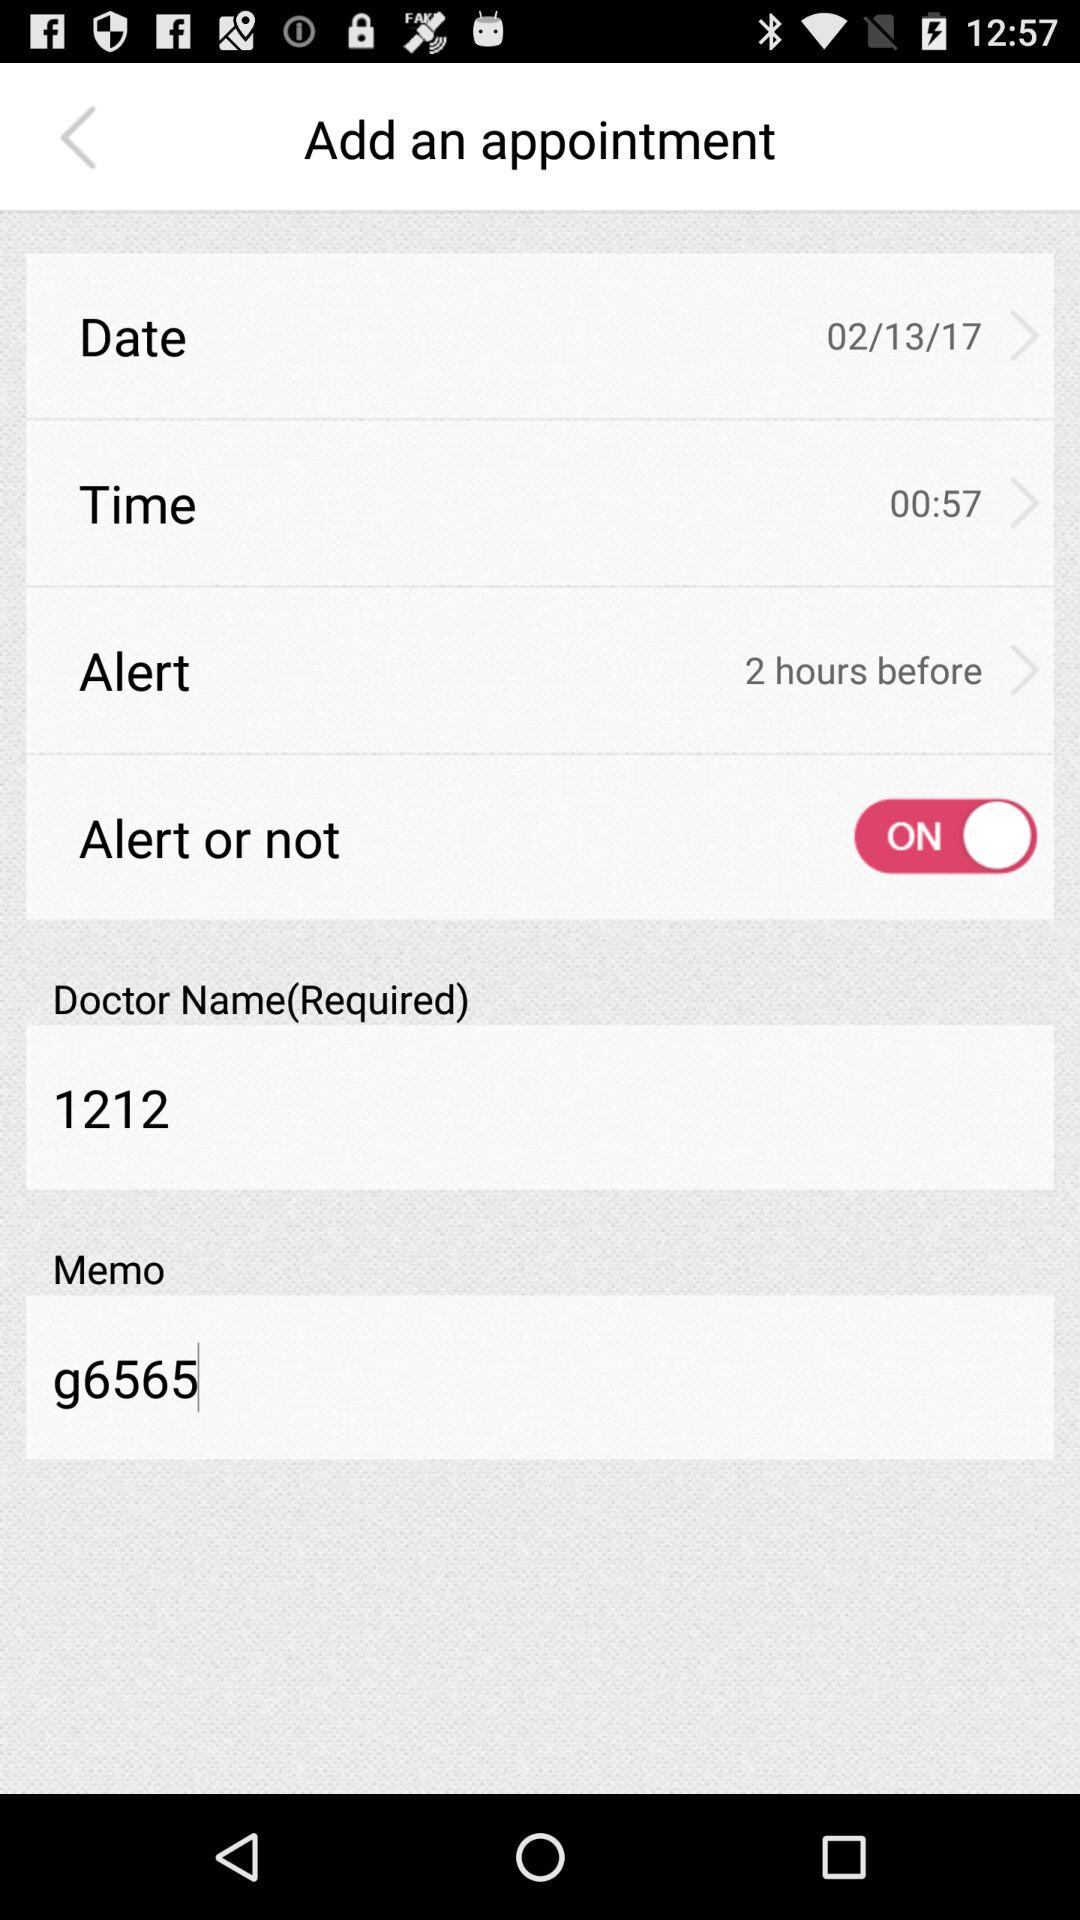What is the memo? The memo is g6565. 